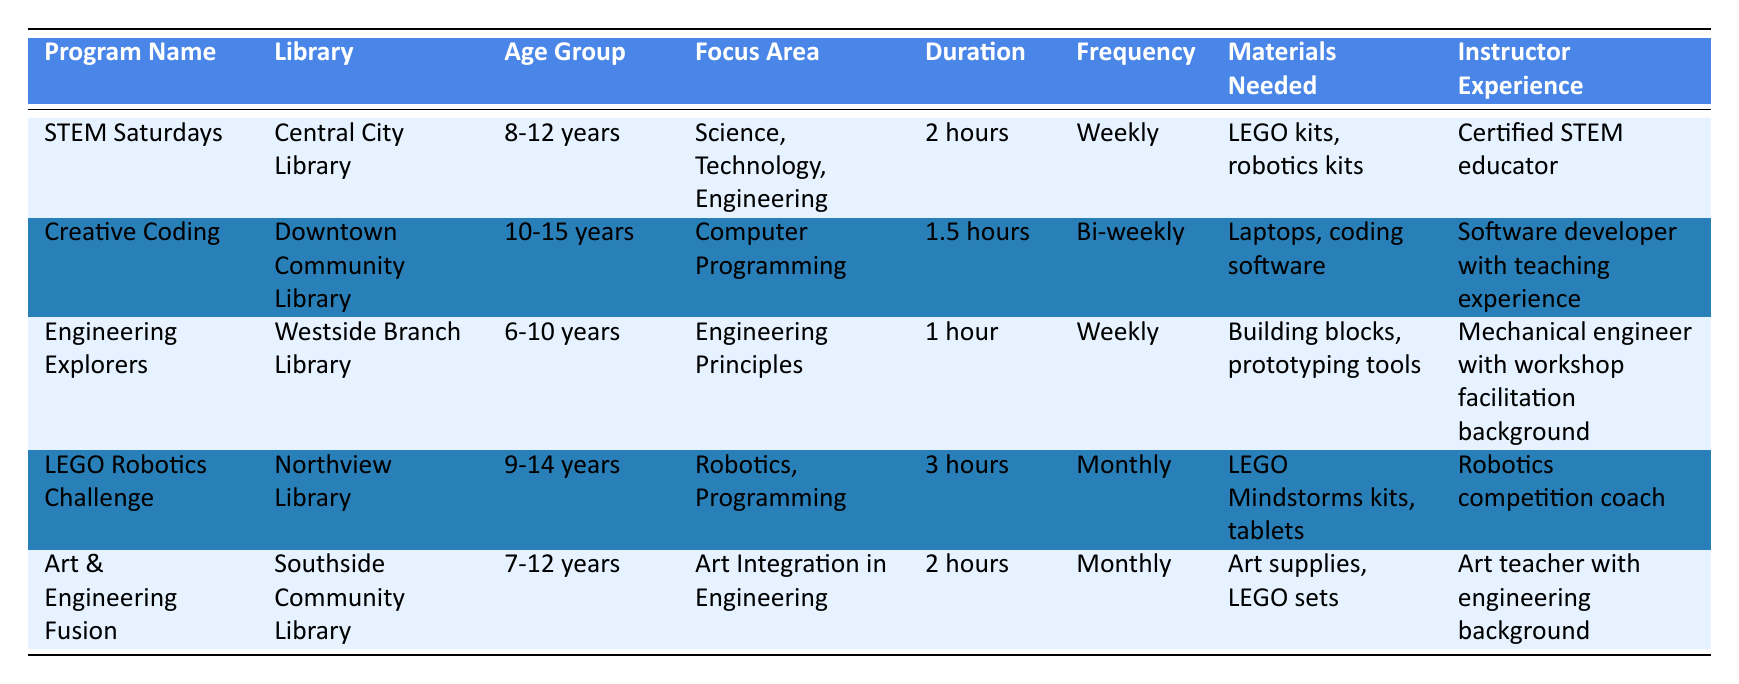What is the duration of the "Creative Coding" program? The table shows the "Creative Coding" program listed under its program name, and in the corresponding column for duration, it states "1.5 hours."
Answer: 1.5 hours Which library offers the "LEGO Robotics Challenge"? By scanning the table for the program named "LEGO Robotics Challenge," it is found that the corresponding library is "Northview Library."
Answer: Northview Library How many programs are offered weekly? The table lists the frequency of each program. "STEM Saturdays" and "Engineering Explorers" are both marked as "Weekly," which gives us a total of 2 programs that are offered weekly.
Answer: 2 Is "Art & Engineering Fusion" aimed at children aged 10-15 years? Looking at the age group listed for "Art & Engineering Fusion," it indicates "7-12 years," which means it is not aimed at the specified age range of 10-15 years.
Answer: No What is the average duration of all the programs listed? The durations of the programs are 2 hours, 1.5 hours, 1 hour, 3 hours, and 2 hours. First, convert all durations into minutes: 120 + 90 + 60 + 180 + 120 = 570 minutes total. To find the average, divide this total by the number of programs (5): 570/5 = 114 minutes, which is equivalent to 1 hour and 54 minutes.
Answer: 1 hour and 54 minutes Which program requires laptops among the materials needed? Scanning the "Materials Needed" column, "Creative Coding" is the only program that lists "Laptops, coding software" as the required materials.
Answer: Creative Coding Does the "Engineering Explorers" program have an instructor with teaching experience in the field? The table indicates that the instructor for this program is a "Mechanical engineer with workshop facilitation background," which implies they have relevant experience, but it does not specifically say they have formal teaching experience. Therefore, the answer is somewhat negative.
Answer: No What is the total number of programs that focus on engineering? The programs that focus on engineering principles, robotics, or art integration in engineering are "STEM Saturdays," "Engineering Explorers," "LEGO Robotics Challenge," and "Art & Engineering Fusion." Counting these gives a total of 4 programs focusing on engineering.
Answer: 4 